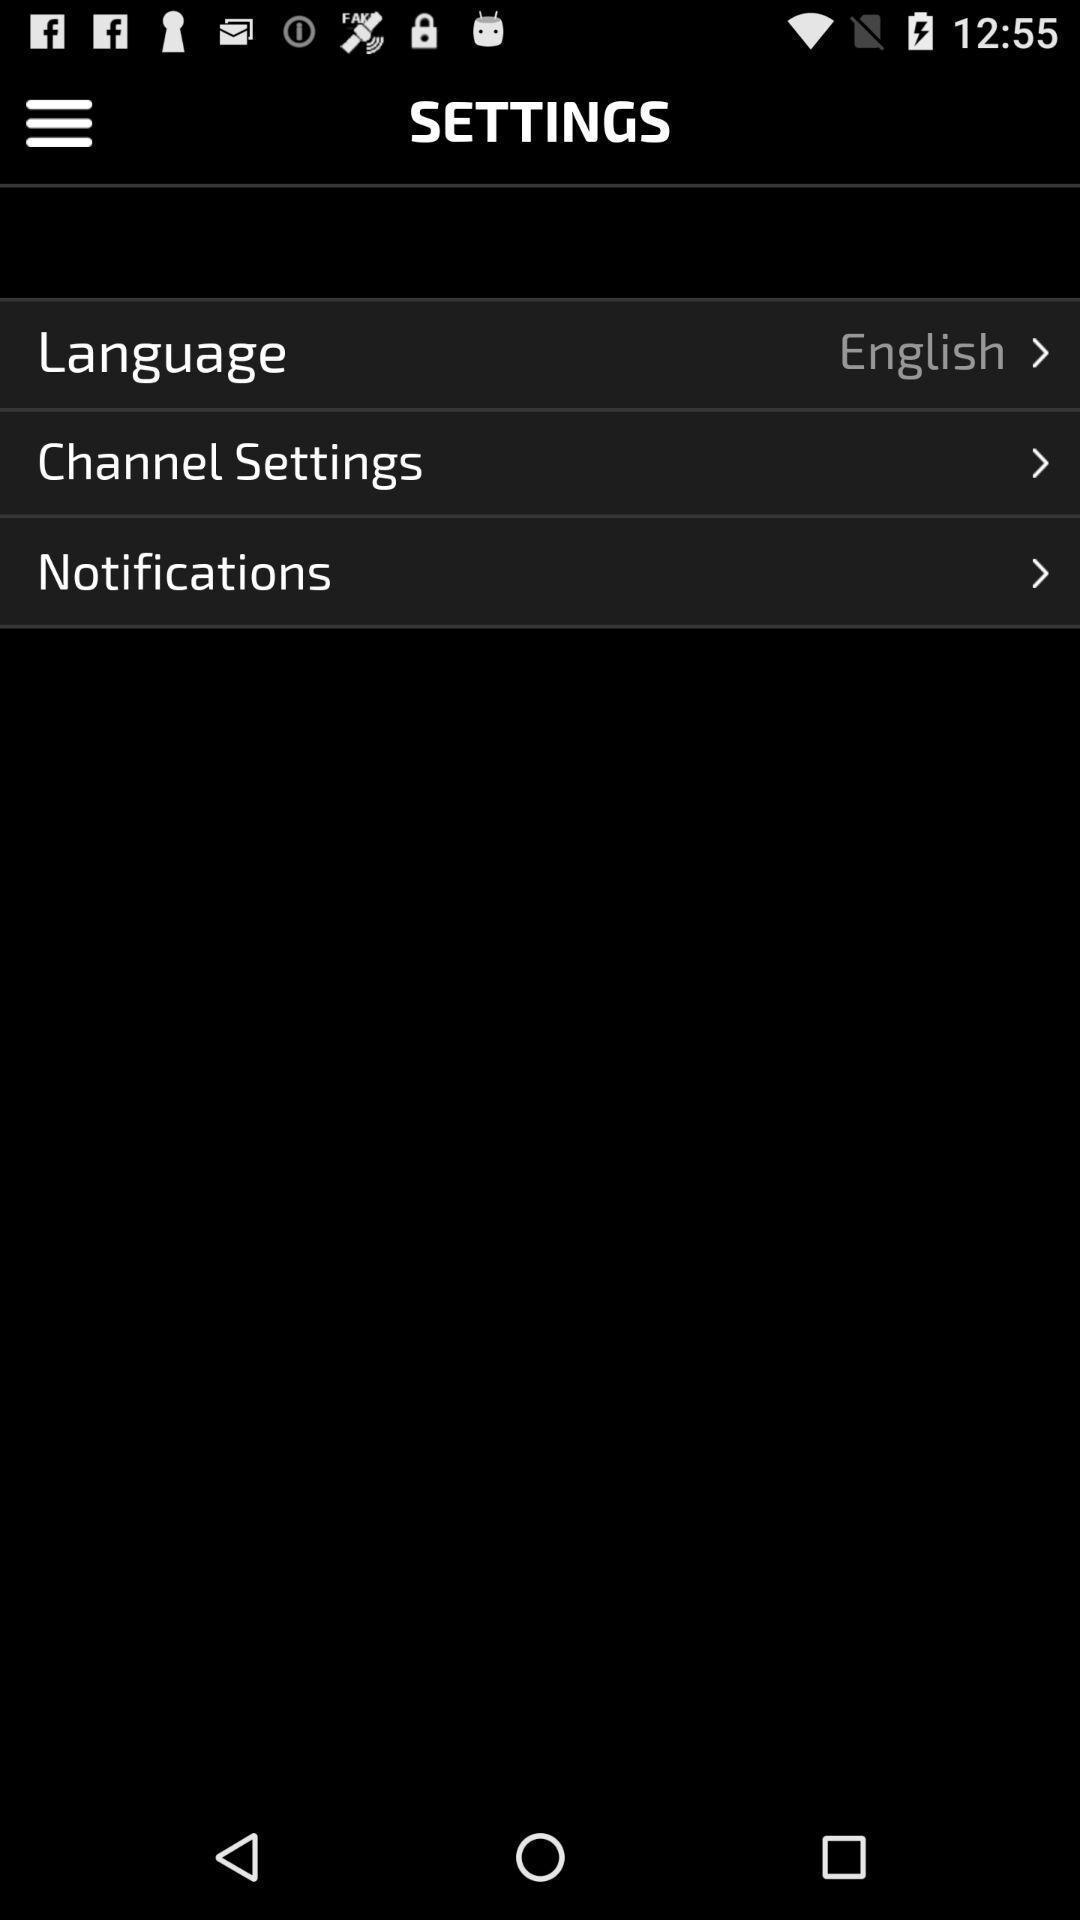Explain the elements present in this screenshot. Settings screen of the app. 